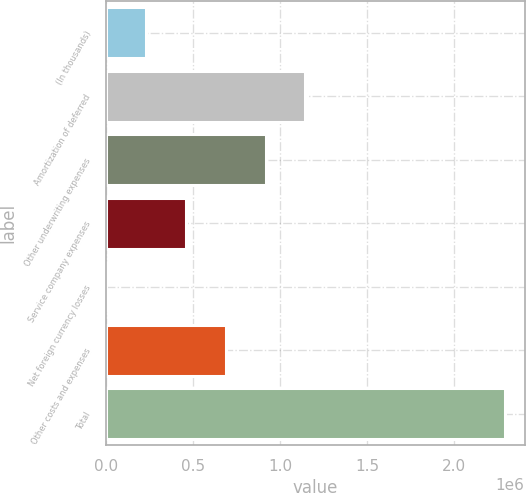Convert chart to OTSL. <chart><loc_0><loc_0><loc_500><loc_500><bar_chart><fcel>(In thousands)<fcel>Amortization of deferred<fcel>Other underwriting expenses<fcel>Service company expenses<fcel>Net foreign currency losses<fcel>Other costs and expenses<fcel>Total<nl><fcel>229335<fcel>1.14508e+06<fcel>916140<fcel>458270<fcel>400<fcel>687205<fcel>2.28975e+06<nl></chart> 